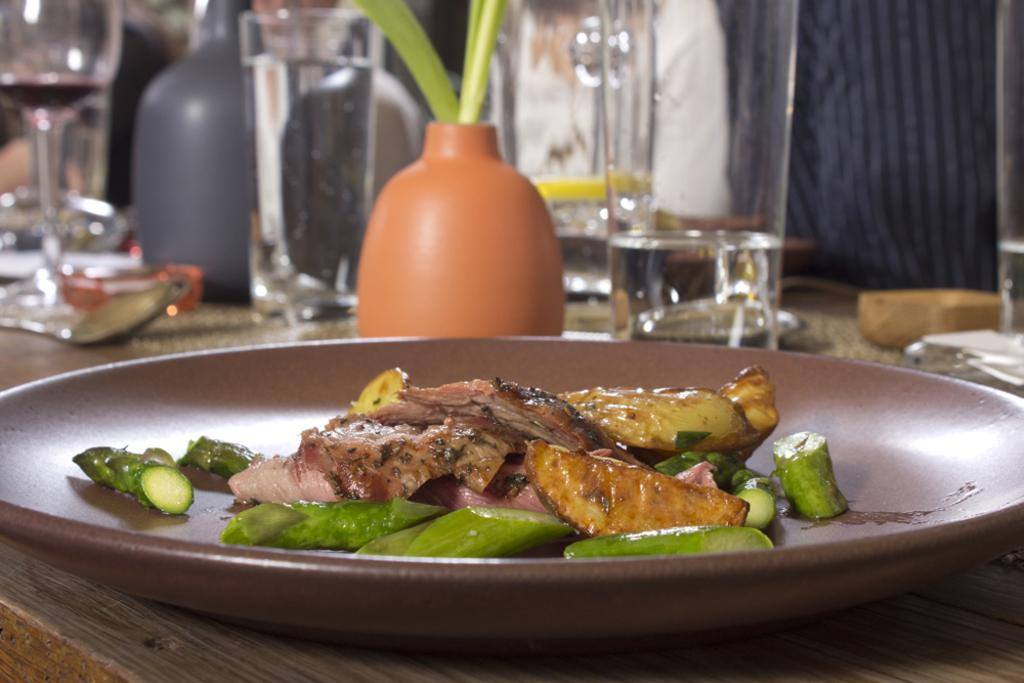What type of food is served on the plate in the image? There is cooked food served on a plate in the image. What can be seen around the plate in the image? There are glasses and other objects around the plate in the image. What type of creature is responsible for serving the food on the plate in the image? There is no creature present in the image; the food is already served on the plate. 